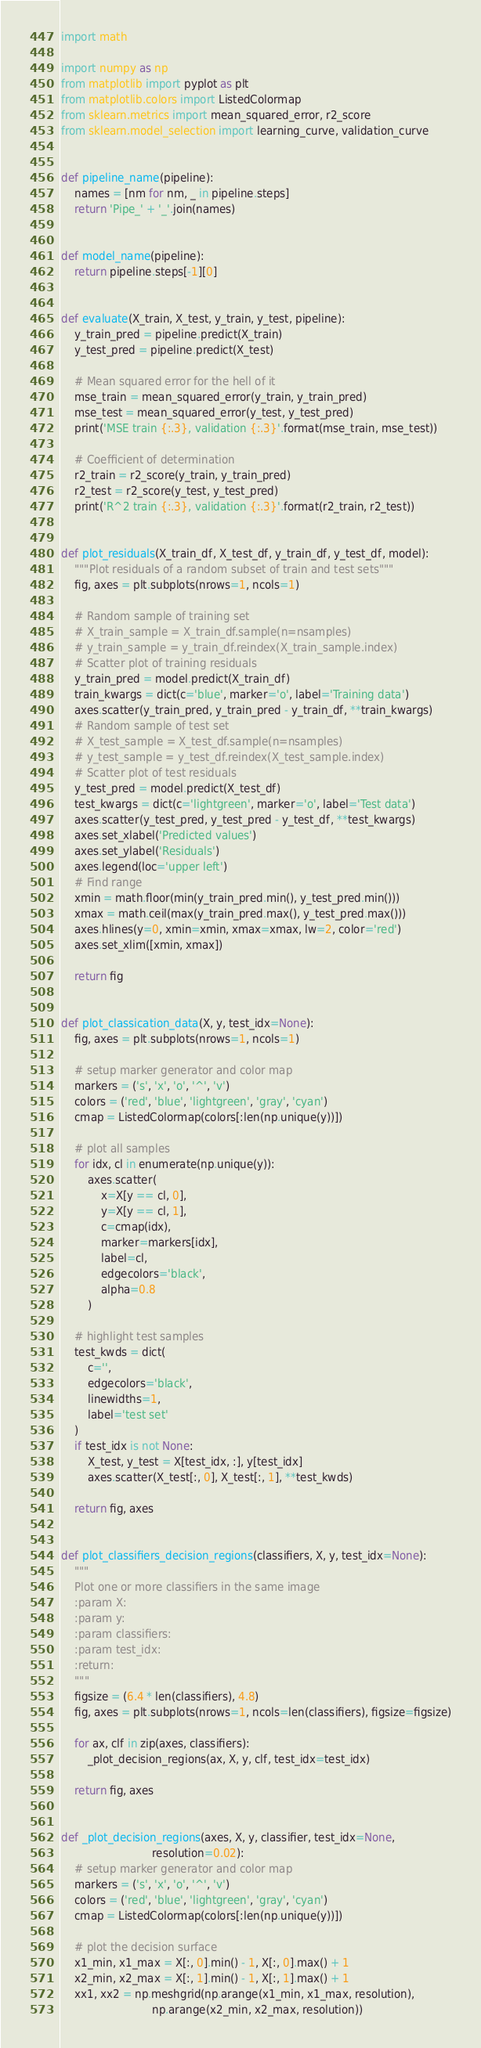<code> <loc_0><loc_0><loc_500><loc_500><_Python_>import math

import numpy as np
from matplotlib import pyplot as plt
from matplotlib.colors import ListedColormap
from sklearn.metrics import mean_squared_error, r2_score
from sklearn.model_selection import learning_curve, validation_curve


def pipeline_name(pipeline):
    names = [nm for nm, _ in pipeline.steps]
    return 'Pipe_' + '_'.join(names)


def model_name(pipeline):
    return pipeline.steps[-1][0]


def evaluate(X_train, X_test, y_train, y_test, pipeline):
    y_train_pred = pipeline.predict(X_train)
    y_test_pred = pipeline.predict(X_test)

    # Mean squared error for the hell of it
    mse_train = mean_squared_error(y_train, y_train_pred)
    mse_test = mean_squared_error(y_test, y_test_pred)
    print('MSE train {:.3}, validation {:.3}'.format(mse_train, mse_test))

    # Coefficient of determination
    r2_train = r2_score(y_train, y_train_pred)
    r2_test = r2_score(y_test, y_test_pred)
    print('R^2 train {:.3}, validation {:.3}'.format(r2_train, r2_test))


def plot_residuals(X_train_df, X_test_df, y_train_df, y_test_df, model):
    """Plot residuals of a random subset of train and test sets"""
    fig, axes = plt.subplots(nrows=1, ncols=1)

    # Random sample of training set
    # X_train_sample = X_train_df.sample(n=nsamples)
    # y_train_sample = y_train_df.reindex(X_train_sample.index)
    # Scatter plot of training residuals
    y_train_pred = model.predict(X_train_df)
    train_kwargs = dict(c='blue', marker='o', label='Training data')
    axes.scatter(y_train_pred, y_train_pred - y_train_df, **train_kwargs)
    # Random sample of test set
    # X_test_sample = X_test_df.sample(n=nsamples)
    # y_test_sample = y_test_df.reindex(X_test_sample.index)
    # Scatter plot of test residuals
    y_test_pred = model.predict(X_test_df)
    test_kwargs = dict(c='lightgreen', marker='o', label='Test data')
    axes.scatter(y_test_pred, y_test_pred - y_test_df, **test_kwargs)
    axes.set_xlabel('Predicted values')
    axes.set_ylabel('Residuals')
    axes.legend(loc='upper left')
    # Find range
    xmin = math.floor(min(y_train_pred.min(), y_test_pred.min()))
    xmax = math.ceil(max(y_train_pred.max(), y_test_pred.max()))
    axes.hlines(y=0, xmin=xmin, xmax=xmax, lw=2, color='red')
    axes.set_xlim([xmin, xmax])

    return fig


def plot_classication_data(X, y, test_idx=None):
    fig, axes = plt.subplots(nrows=1, ncols=1)

    # setup marker generator and color map
    markers = ('s', 'x', 'o', '^', 'v')
    colors = ('red', 'blue', 'lightgreen', 'gray', 'cyan')
    cmap = ListedColormap(colors[:len(np.unique(y))])

    # plot all samples
    for idx, cl in enumerate(np.unique(y)):
        axes.scatter(
            x=X[y == cl, 0],
            y=X[y == cl, 1],
            c=cmap(idx),
            marker=markers[idx],
            label=cl,
            edgecolors='black',
            alpha=0.8
        )

    # highlight test samples
    test_kwds = dict(
        c='',
        edgecolors='black',
        linewidths=1,
        label='test set'
    )
    if test_idx is not None:
        X_test, y_test = X[test_idx, :], y[test_idx]
        axes.scatter(X_test[:, 0], X_test[:, 1], **test_kwds)

    return fig, axes


def plot_classifiers_decision_regions(classifiers, X, y, test_idx=None):
    """
    Plot one or more classifiers in the same image
    :param X:
    :param y:
    :param classifiers:
    :param test_idx:
    :return:
    """
    figsize = (6.4 * len(classifiers), 4.8)
    fig, axes = plt.subplots(nrows=1, ncols=len(classifiers), figsize=figsize)

    for ax, clf in zip(axes, classifiers):
        _plot_decision_regions(ax, X, y, clf, test_idx=test_idx)

    return fig, axes


def _plot_decision_regions(axes, X, y, classifier, test_idx=None,
                           resolution=0.02):
    # setup marker generator and color map
    markers = ('s', 'x', 'o', '^', 'v')
    colors = ('red', 'blue', 'lightgreen', 'gray', 'cyan')
    cmap = ListedColormap(colors[:len(np.unique(y))])

    # plot the decision surface
    x1_min, x1_max = X[:, 0].min() - 1, X[:, 0].max() + 1
    x2_min, x2_max = X[:, 1].min() - 1, X[:, 1].max() + 1
    xx1, xx2 = np.meshgrid(np.arange(x1_min, x1_max, resolution),
                           np.arange(x2_min, x2_max, resolution))</code> 